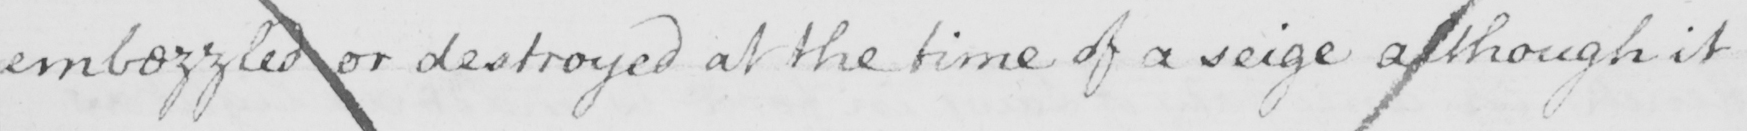Can you tell me what this handwritten text says? embezzled or destroyed at the time of a seige although it 